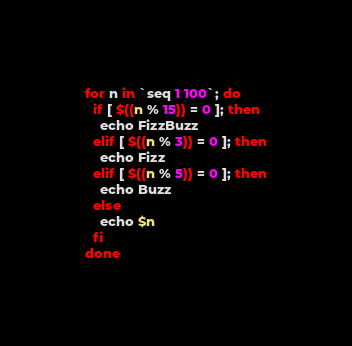<code> <loc_0><loc_0><loc_500><loc_500><_Bash_>for n in `seq 1 100`; do
  if [ $((n % 15)) = 0 ]; then
    echo FizzBuzz
  elif [ $((n % 3)) = 0 ]; then
    echo Fizz
  elif [ $((n % 5)) = 0 ]; then
    echo Buzz
  else
    echo $n
  fi
done
</code> 